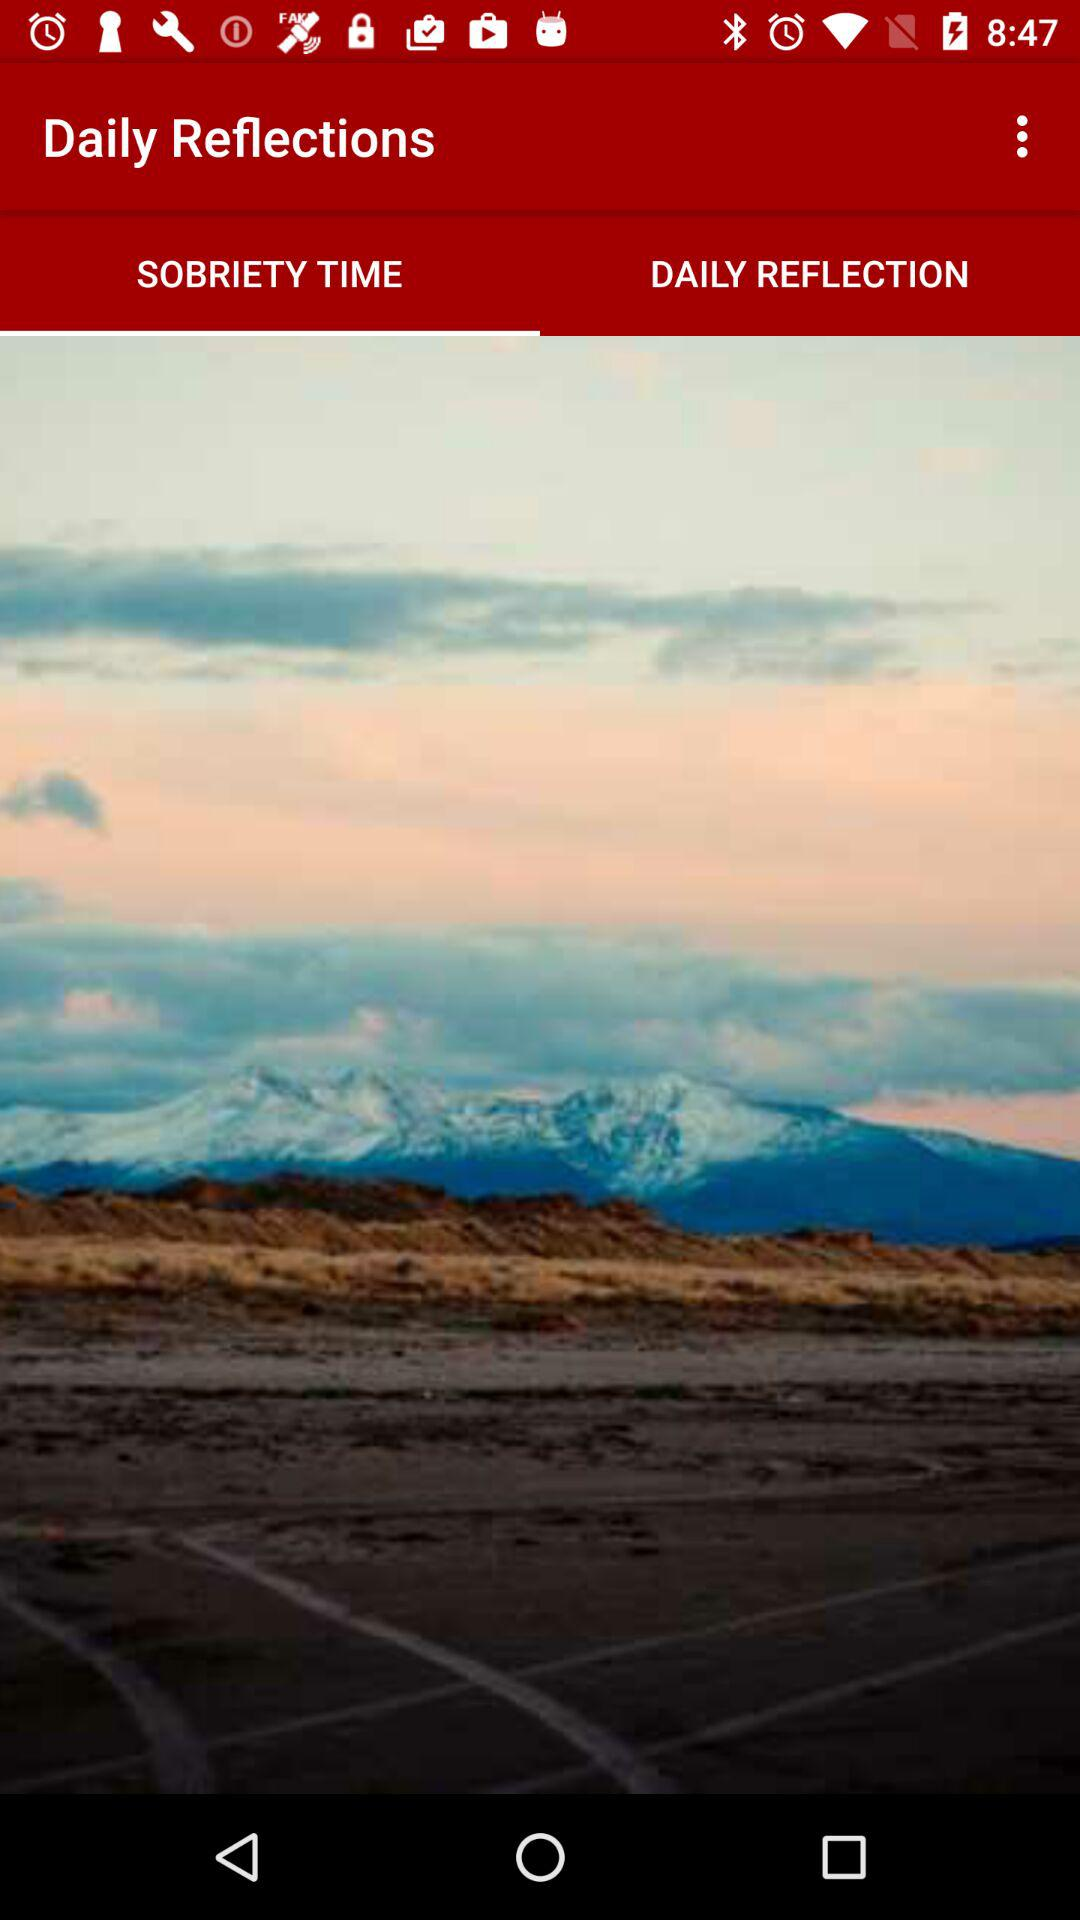Which tab is selected? The selected tab is "SOBRIETY TIME". 